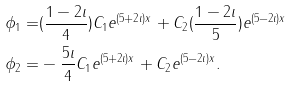Convert formula to latex. <formula><loc_0><loc_0><loc_500><loc_500>\phi _ { 1 } = & ( \frac { 1 - 2 \imath } { 4 } ) C _ { 1 } e ^ { ( 5 + 2 \imath ) x } + C _ { 2 } ( \frac { 1 - 2 \imath } { 5 } ) e ^ { ( 5 - 2 \imath ) x } \\ \phi _ { 2 } = & - \frac { 5 \imath } { 4 } C _ { 1 } e ^ { ( 5 + 2 \imath ) x } + C _ { 2 } e ^ { ( 5 - 2 \imath ) x } .</formula> 